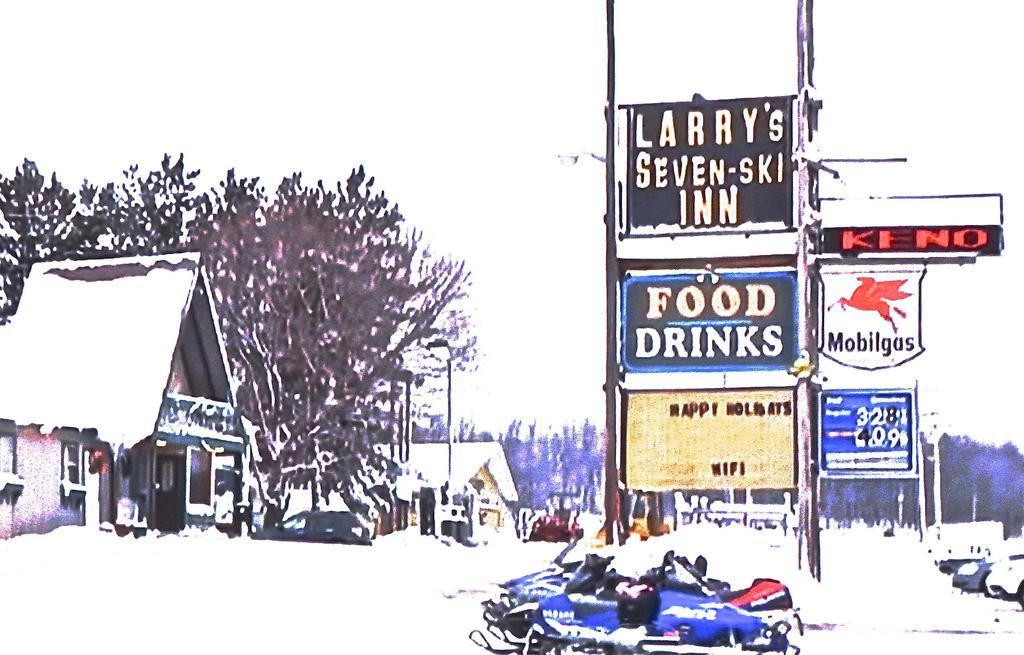Describe this image in one or two sentences. In this image in the front there are bikes and in the center there are boards with some text written on it. In the background there are trees and there are houses. 